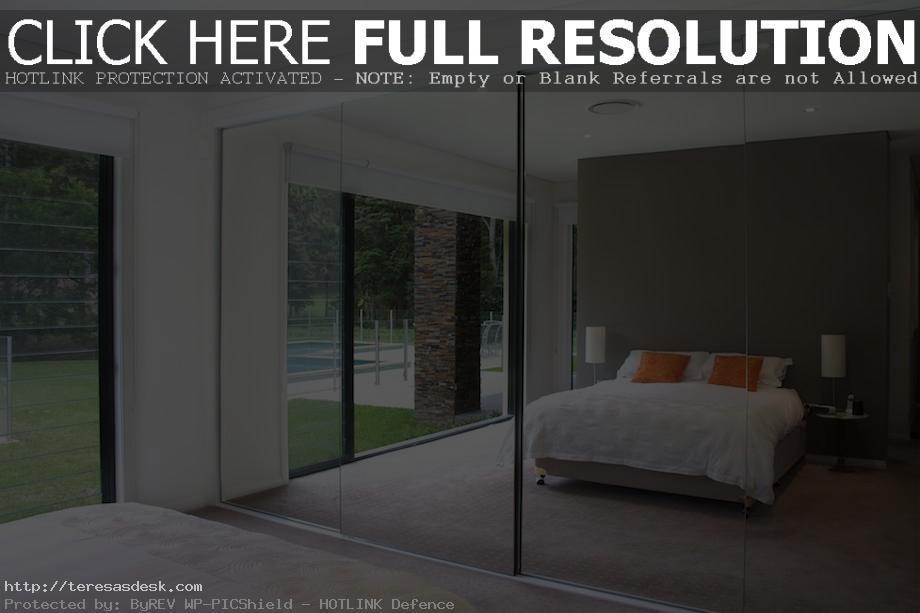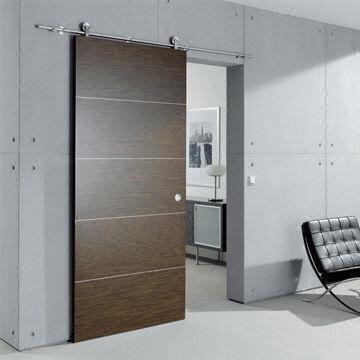The first image is the image on the left, the second image is the image on the right. Given the left and right images, does the statement "In each room there are mirrored sliding doors on the closet." hold true? Answer yes or no. No. 